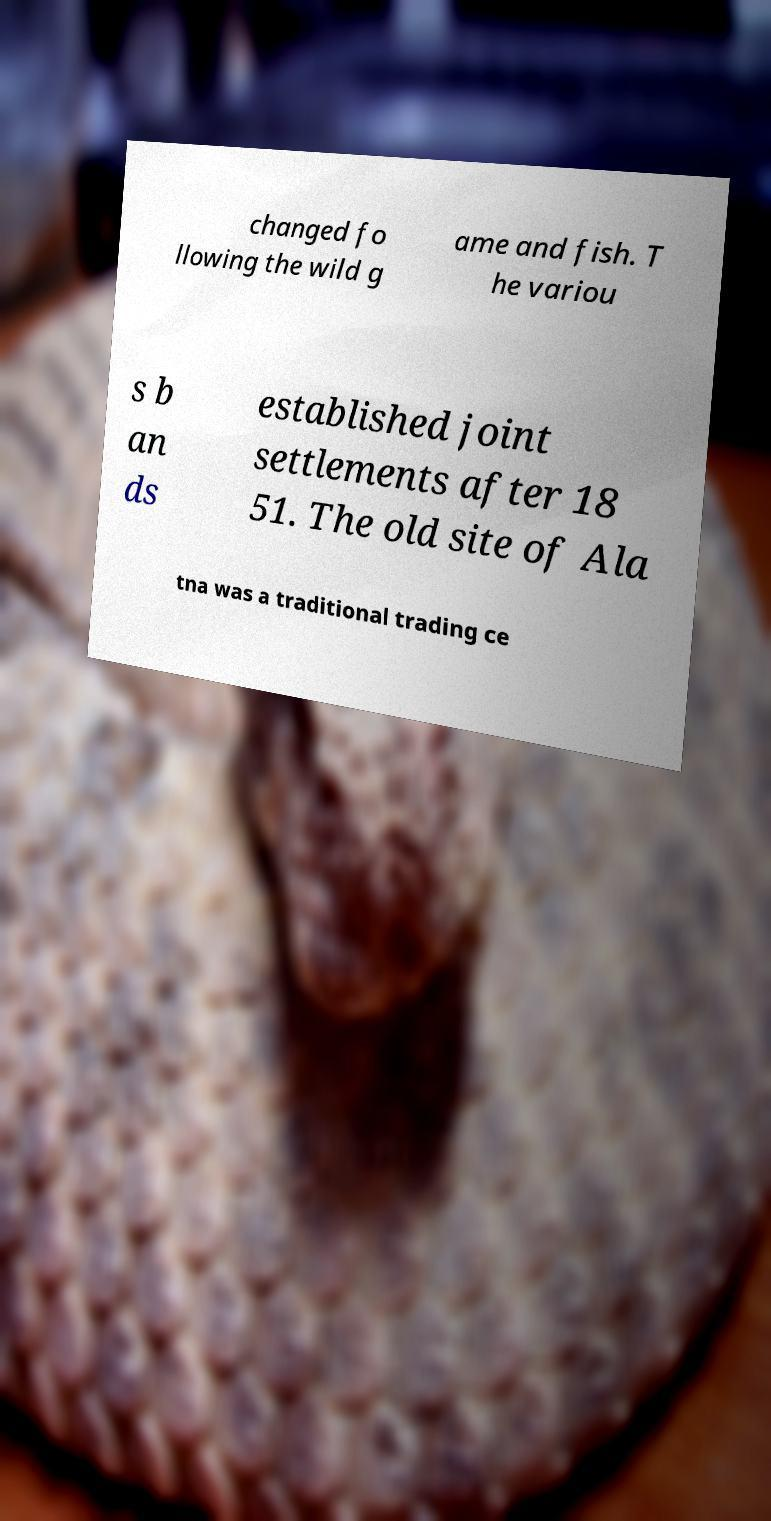What messages or text are displayed in this image? I need them in a readable, typed format. changed fo llowing the wild g ame and fish. T he variou s b an ds established joint settlements after 18 51. The old site of Ala tna was a traditional trading ce 